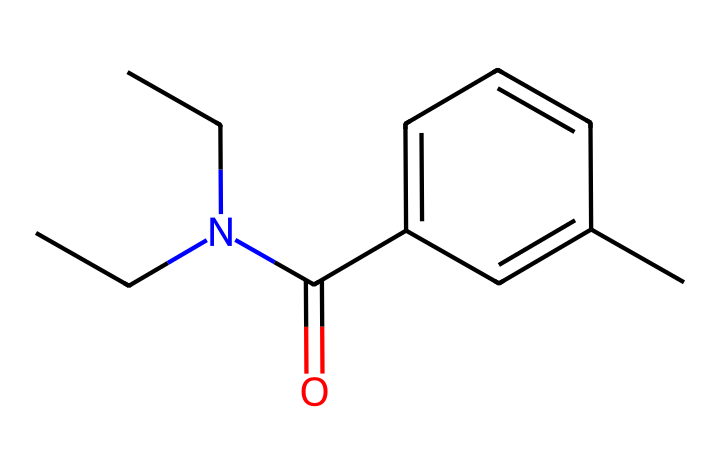What is the main functional group in this compound? The structure contains a carbonyl group (C=O) attached to an aromatic ring, indicating the presence of an amide functional group due to the nitrogen and carbonyl connection.
Answer: amide How many nitrogen atoms are in this molecule? The SMILES representation shows two 'N' symbols, indicating there are two nitrogen atoms present in the structure.
Answer: two What is the molecular formula of this compound? By analyzing the SMILES representation, counting the carbon (C), hydrogen (H), nitrogen (N), and oxygen (O) atoms yields a molecular formula of C13H17N2O.
Answer: C13H17N2O Which structural element indicates this compound is aromatic? The presence of the six-membered carbon ring with alternating double bonds (represented by 'c' in the SMILES) signifies that this compound contains an aromatic system.
Answer: aromatic ring How many carbon atoms are part of the aromatic ring? The 'c' symbols in the SMILES string represent the carbon atoms in the aromatic system; counting them reveals there are five carbon atoms in the ring.
Answer: five What type of insect repellent category does this compound belong to? The compound is often categorized as a synthetic repellent due to its organic structure derived from chemical synthesis rather than natural sources.
Answer: synthetic How many branches does this compound have? The structure shows one branching point at the nitrogen atom where two ethyl groups are attached, indicating a single branching in the molecule.
Answer: one 